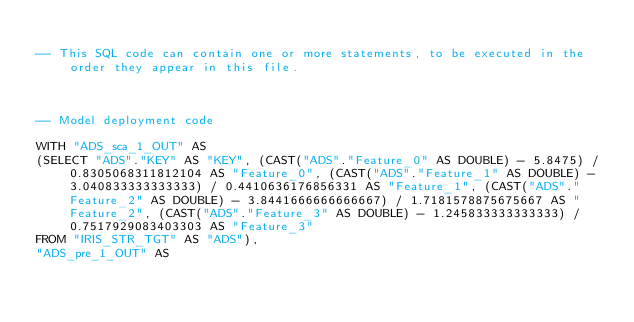<code> <loc_0><loc_0><loc_500><loc_500><_SQL_>
-- This SQL code can contain one or more statements, to be executed in the order they appear in this file.



-- Model deployment code

WITH "ADS_sca_1_OUT" AS 
(SELECT "ADS"."KEY" AS "KEY", (CAST("ADS"."Feature_0" AS DOUBLE) - 5.8475) / 0.8305068311812104 AS "Feature_0", (CAST("ADS"."Feature_1" AS DOUBLE) - 3.040833333333333) / 0.4410636176856331 AS "Feature_1", (CAST("ADS"."Feature_2" AS DOUBLE) - 3.8441666666666667) / 1.7181578875675667 AS "Feature_2", (CAST("ADS"."Feature_3" AS DOUBLE) - 1.245833333333333) / 0.7517929083403303 AS "Feature_3" 
FROM "IRIS_STR_TGT" AS "ADS"), 
"ADS_pre_1_OUT" AS </code> 